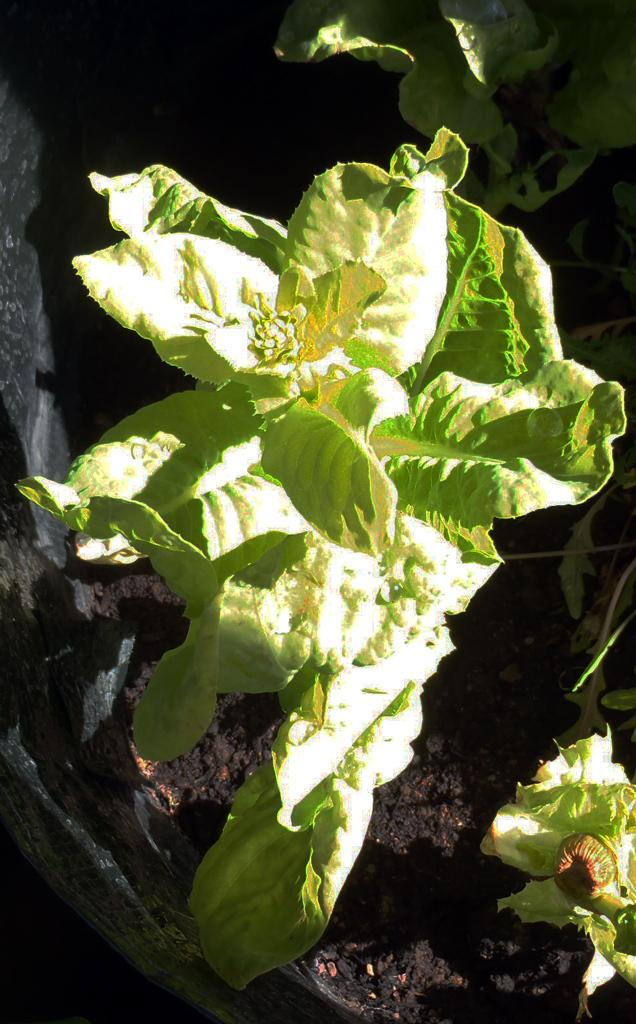What type of plant material can be seen in the image? There are leaves and stems in the image. Can you describe the container in the background of the image? There is a pot in the background of the image. What type of lunch is being served in the image? There is no lunch present in the image; it features leaves, stems, and a pot. How does the paste appear in the image? There is no paste present in the image. 